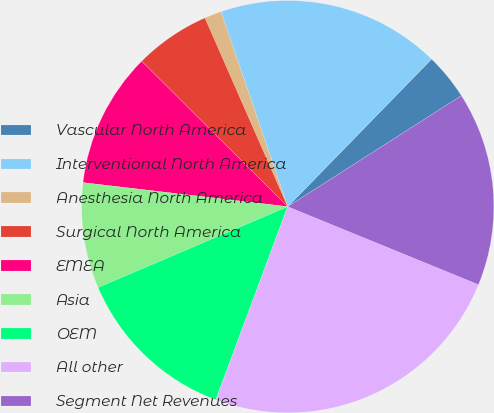Convert chart to OTSL. <chart><loc_0><loc_0><loc_500><loc_500><pie_chart><fcel>Vascular North America<fcel>Interventional North America<fcel>Anesthesia North America<fcel>Surgical North America<fcel>EMEA<fcel>Asia<fcel>OEM<fcel>All other<fcel>Segment Net Revenues<nl><fcel>3.65%<fcel>17.55%<fcel>1.33%<fcel>5.96%<fcel>10.6%<fcel>8.28%<fcel>12.91%<fcel>24.5%<fcel>15.23%<nl></chart> 